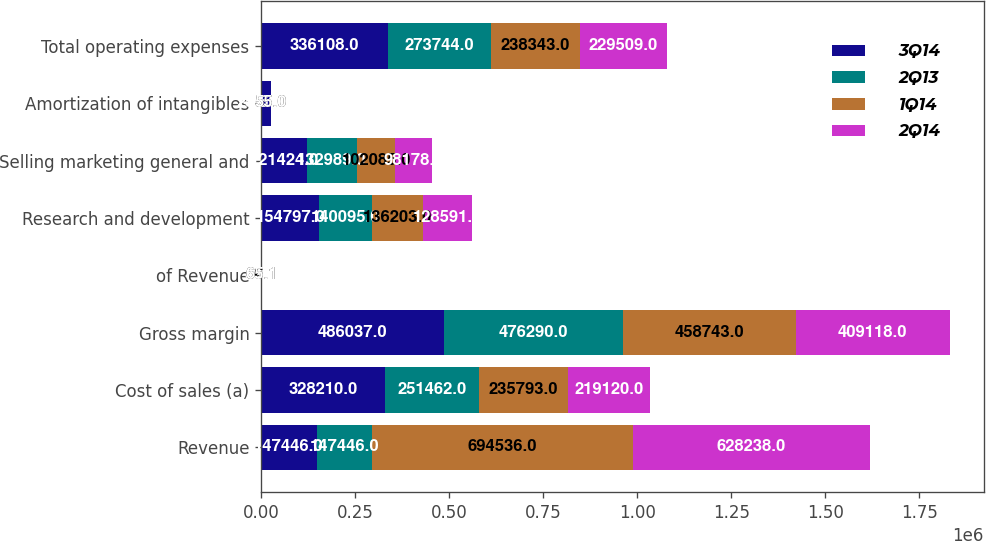Convert chart. <chart><loc_0><loc_0><loc_500><loc_500><stacked_bar_chart><ecel><fcel>Revenue<fcel>Cost of sales (a)<fcel>Gross margin<fcel>of Revenue<fcel>Research and development<fcel>Selling marketing general and<fcel>Amortization of intangibles<fcel>Total operating expenses<nl><fcel>3Q14<fcel>147446<fcel>328210<fcel>486037<fcel>59.7<fcel>154797<fcel>121424<fcel>25250<fcel>336108<nl><fcel>2Q13<fcel>147446<fcel>251462<fcel>476290<fcel>65.4<fcel>140095<fcel>132989<fcel>660<fcel>273744<nl><fcel>1Q14<fcel>694536<fcel>235793<fcel>458743<fcel>66.1<fcel>136203<fcel>102085<fcel>55<fcel>238343<nl><fcel>2Q14<fcel>628238<fcel>219120<fcel>409118<fcel>65.1<fcel>128591<fcel>98178<fcel>55<fcel>229509<nl></chart> 